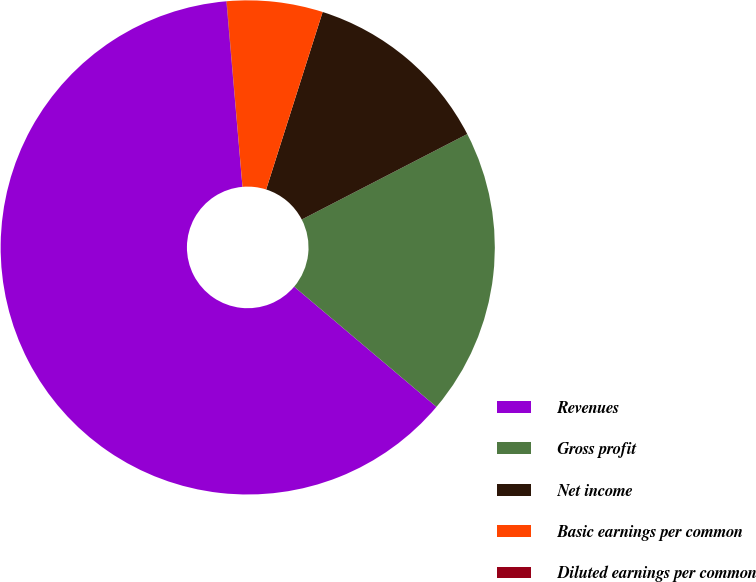Convert chart. <chart><loc_0><loc_0><loc_500><loc_500><pie_chart><fcel>Revenues<fcel>Gross profit<fcel>Net income<fcel>Basic earnings per common<fcel>Diluted earnings per common<nl><fcel>62.46%<fcel>18.75%<fcel>12.51%<fcel>6.26%<fcel>0.02%<nl></chart> 